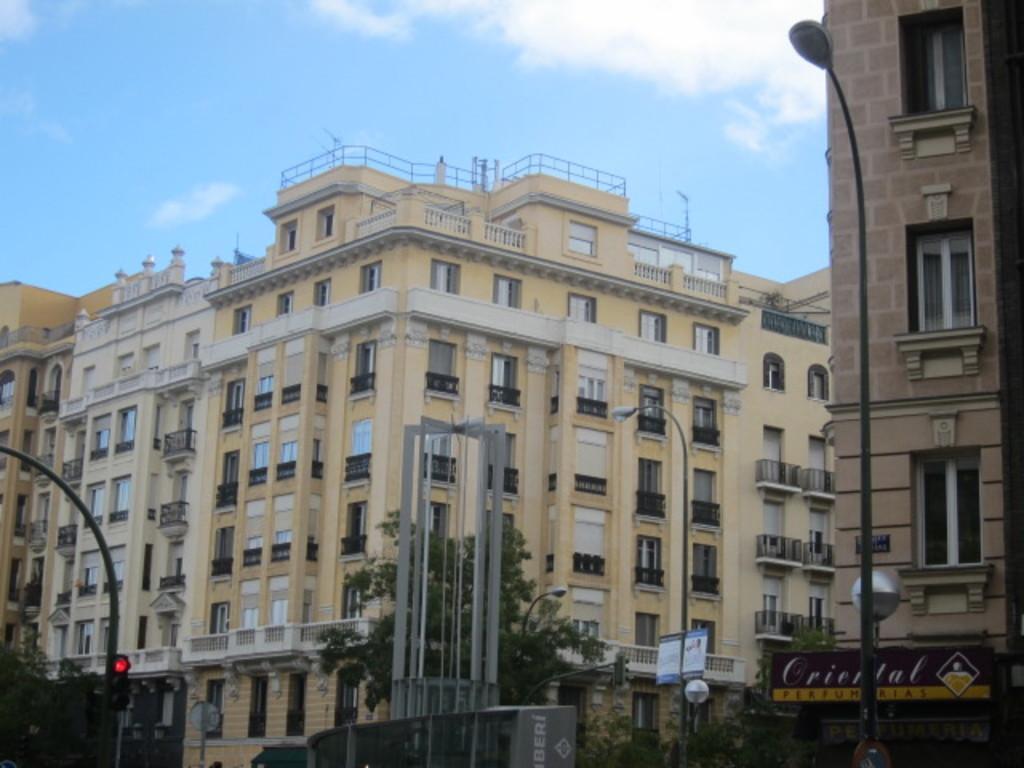Describe this image in one or two sentences. In this image we can see the buildings. Here we can see the metal fencing and antennas on the top of the building. Here we can see the glass windows on the right side. Here we can see the light poles and traffic signal pole. Here we can see the trees. This is a sky with clouds. 